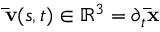<formula> <loc_0><loc_0><loc_500><loc_500>\bar { v } ( s , t ) \in \mathbb { R } ^ { 3 } = \partial _ { t } \bar { x }</formula> 